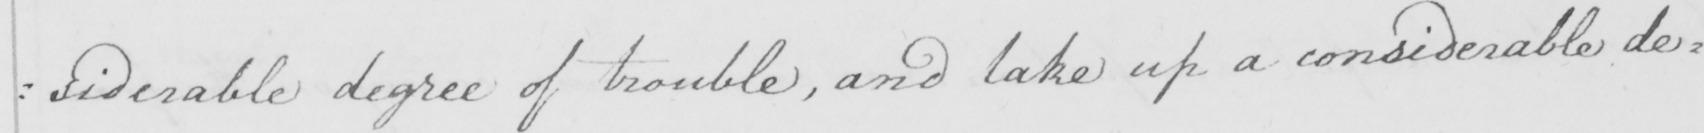What text is written in this handwritten line? : siderable degree of trouble , and take up a considerable de= 